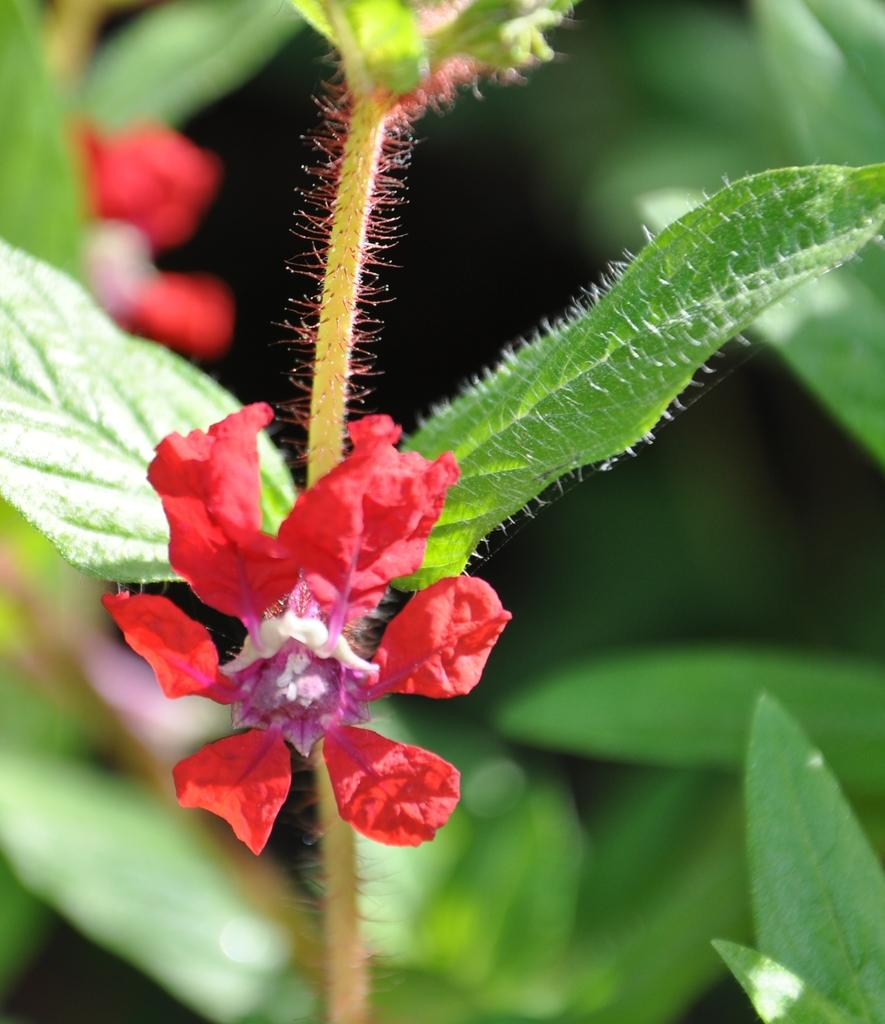What type of flower can be seen in the image? There is a red flower in the image. Where is the red flower located? The red flower is on a plant. What else can be seen in the image besides the red flower? There are many plants visible in the image. What type of straw is being used to build the volcano in the image? There is no straw or volcano present in the image; it features a red flower on a plant and other plants in the background. 